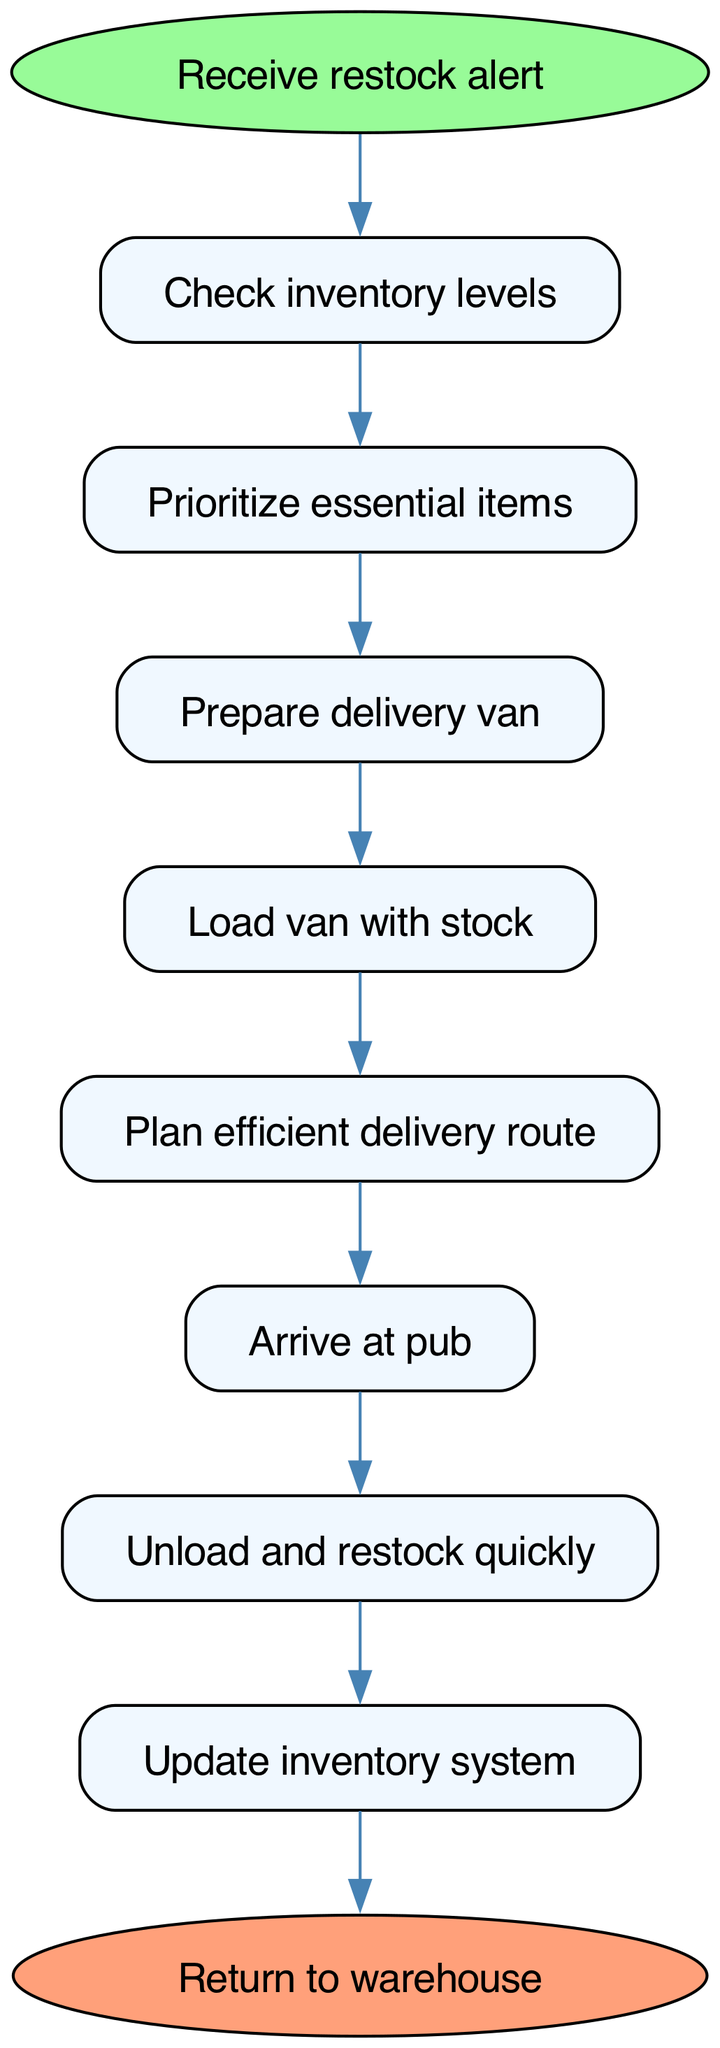What is the starting point of the workflow? The starting point is labeled as "Receive restock alert," which can be identified in the diagram at the beginning where the flow is initiated.
Answer: Receive restock alert What item comes after "Check inventory levels"? The item following "Check inventory levels" is "Prioritize essential items," as indicated by the arrow pointing from the first node to the second node.
Answer: Prioritize essential items How many steps are there in the workflow? The workflow includes eight steps depicted within the flow chart, each clearly represented by its own node, leading up to the final end point.
Answer: Eight What is the final action of the workflow? The final action listed is "Update inventory system," which is the last step before returning to the warehouse.
Answer: Update inventory system Which step involves preparing the delivery vehicle? The step that involves preparing the delivery vehicle is "Prepare delivery van," which is the third action in the sequence leading up to the load.
Answer: Prepare delivery van What comes before "Unload and restock quickly"? The action that precedes "Unload and restock quickly" is "Arrive at pub," as seen in the diagram where the sequence flows from arrival to unloading.
Answer: Arrive at pub Which two steps are directly connected without interruption? The steps "Load van with stock" and "Plan efficient delivery route" are directly connected because there is a direct arrow moving from one to the next without any additional nodes in between.
Answer: Load van with stock and Plan efficient delivery route How does one transition from loading the van to arriving at the pub? The transition from loading the van to arriving at the pub occurs after "Load van with stock," leading directly to "Plan efficient delivery route," then continuing to "Arrive at pub," which follows the established flow.
Answer: Through planning the efficient delivery route What is the purpose of prioritizing essential items? The purpose of prioritizing essential items is to ensure that the most critical supplies are restocked first, which helps maintain service during peak hours. This step is essential for efficiency, as shown in the diagram.
Answer: To ensure critical supplies are restocked first 